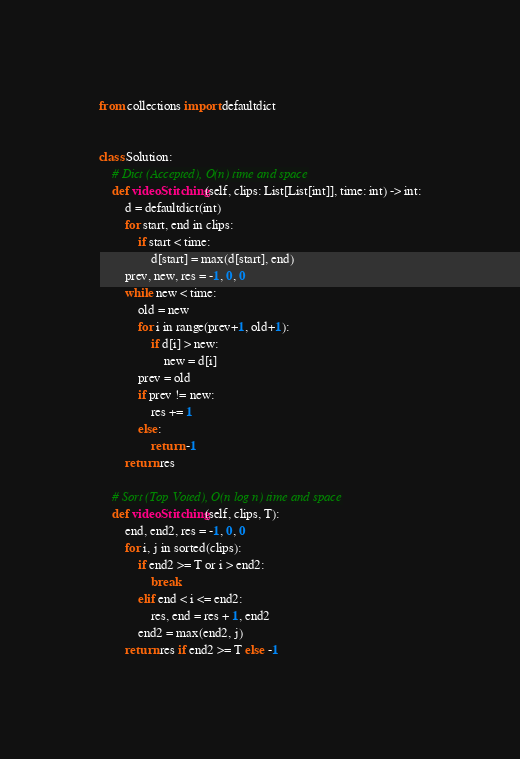<code> <loc_0><loc_0><loc_500><loc_500><_Python_>from collections import defaultdict


class Solution:
    # Dict (Accepted), O(n) time and space
    def videoStitching(self, clips: List[List[int]], time: int) -> int:
        d = defaultdict(int)
        for start, end in clips:
            if start < time:
                d[start] = max(d[start], end)
        prev, new, res = -1, 0, 0
        while new < time:
            old = new
            for i in range(prev+1, old+1):
                if d[i] > new:
                    new = d[i]
            prev = old
            if prev != new:
                res += 1
            else:
                return -1
        return res

    # Sort (Top Voted), O(n log n) time and space
    def videoStitching(self, clips, T):
        end, end2, res = -1, 0, 0
        for i, j in sorted(clips):
            if end2 >= T or i > end2:
                break
            elif end < i <= end2:
                res, end = res + 1, end2
            end2 = max(end2, j)
        return res if end2 >= T else -1
</code> 